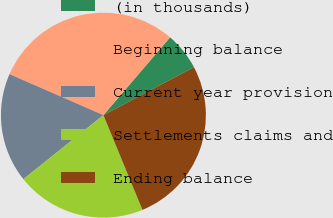Convert chart. <chart><loc_0><loc_0><loc_500><loc_500><pie_chart><fcel>(in thousands)<fcel>Beginning balance<fcel>Current year provision<fcel>Settlements claims and<fcel>Ending balance<nl><fcel>5.97%<fcel>29.72%<fcel>17.29%<fcel>20.48%<fcel>26.53%<nl></chart> 